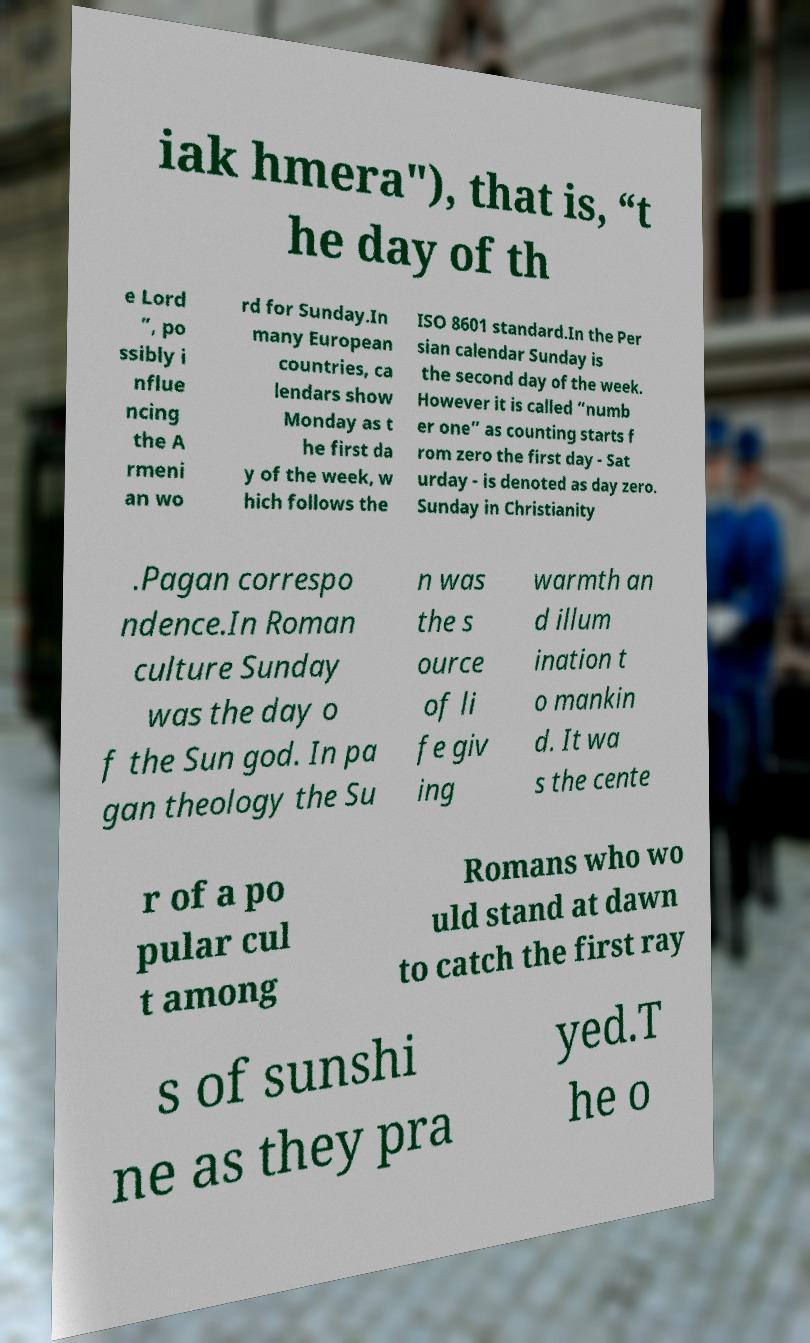There's text embedded in this image that I need extracted. Can you transcribe it verbatim? iak hmera"), that is, “t he day of th e Lord ”, po ssibly i nflue ncing the A rmeni an wo rd for Sunday.In many European countries, ca lendars show Monday as t he first da y of the week, w hich follows the ISO 8601 standard.In the Per sian calendar Sunday is the second day of the week. However it is called “numb er one” as counting starts f rom zero the first day - Sat urday - is denoted as day zero. Sunday in Christianity .Pagan correspo ndence.In Roman culture Sunday was the day o f the Sun god. In pa gan theology the Su n was the s ource of li fe giv ing warmth an d illum ination t o mankin d. It wa s the cente r of a po pular cul t among Romans who wo uld stand at dawn to catch the first ray s of sunshi ne as they pra yed.T he o 